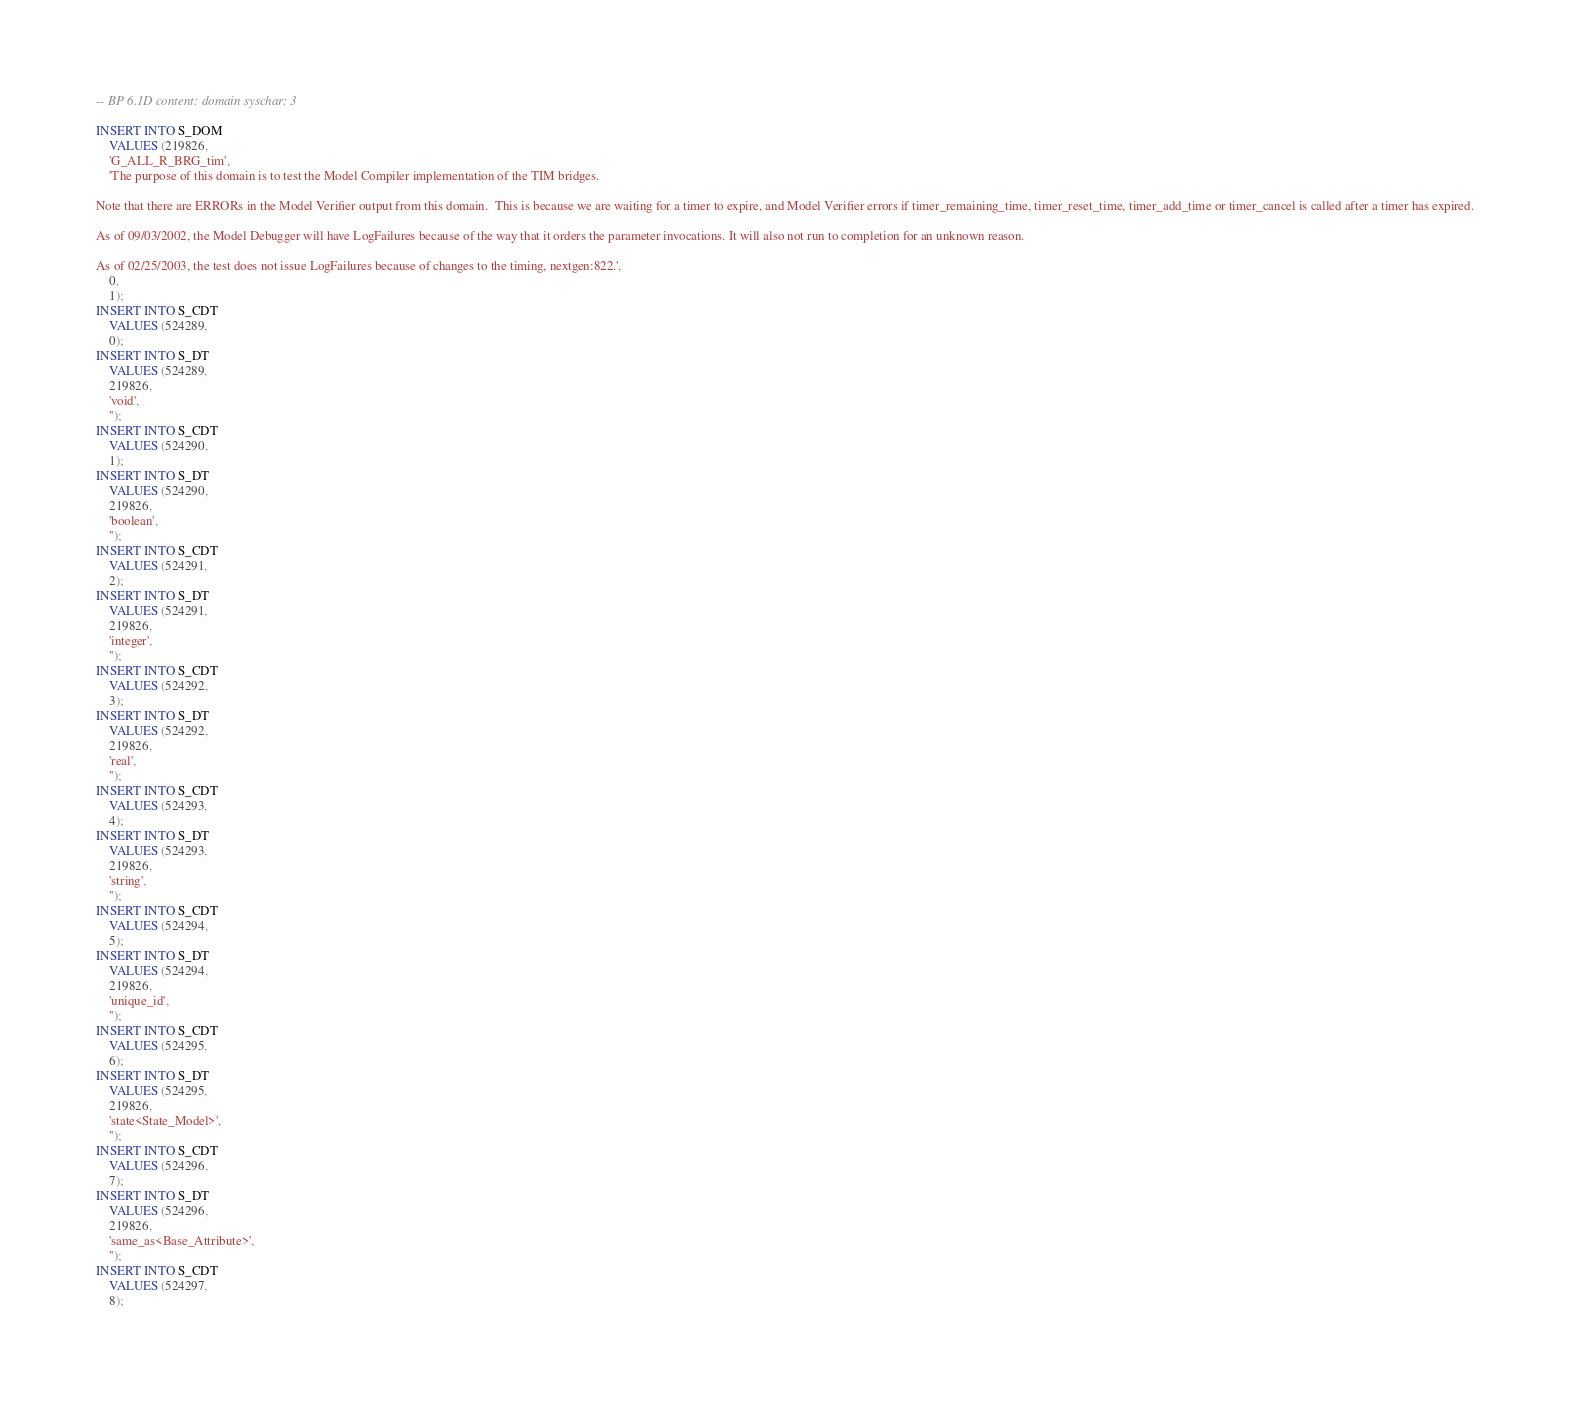Convert code to text. <code><loc_0><loc_0><loc_500><loc_500><_SQL_>-- BP 6.1D content: domain syschar: 3

INSERT INTO S_DOM
	VALUES (219826,
	'G_ALL_R_BRG_tim',
	'The purpose of this domain is to test the Model Compiler implementation of the TIM bridges.

Note that there are ERRORs in the Model Verifier output from this domain.  This is because we are waiting for a timer to expire, and Model Verifier errors if timer_remaining_time, timer_reset_time, timer_add_time or timer_cancel is called after a timer has expired.

As of 09/03/2002, the Model Debugger will have LogFailures because of the way that it orders the parameter invocations. It will also not run to completion for an unknown reason.

As of 02/25/2003, the test does not issue LogFailures because of changes to the timing, nextgen:822.',
	0,
	1);
INSERT INTO S_CDT
	VALUES (524289,
	0);
INSERT INTO S_DT
	VALUES (524289,
	219826,
	'void',
	'');
INSERT INTO S_CDT
	VALUES (524290,
	1);
INSERT INTO S_DT
	VALUES (524290,
	219826,
	'boolean',
	'');
INSERT INTO S_CDT
	VALUES (524291,
	2);
INSERT INTO S_DT
	VALUES (524291,
	219826,
	'integer',
	'');
INSERT INTO S_CDT
	VALUES (524292,
	3);
INSERT INTO S_DT
	VALUES (524292,
	219826,
	'real',
	'');
INSERT INTO S_CDT
	VALUES (524293,
	4);
INSERT INTO S_DT
	VALUES (524293,
	219826,
	'string',
	'');
INSERT INTO S_CDT
	VALUES (524294,
	5);
INSERT INTO S_DT
	VALUES (524294,
	219826,
	'unique_id',
	'');
INSERT INTO S_CDT
	VALUES (524295,
	6);
INSERT INTO S_DT
	VALUES (524295,
	219826,
	'state<State_Model>',
	'');
INSERT INTO S_CDT
	VALUES (524296,
	7);
INSERT INTO S_DT
	VALUES (524296,
	219826,
	'same_as<Base_Attribute>',
	'');
INSERT INTO S_CDT
	VALUES (524297,
	8);</code> 